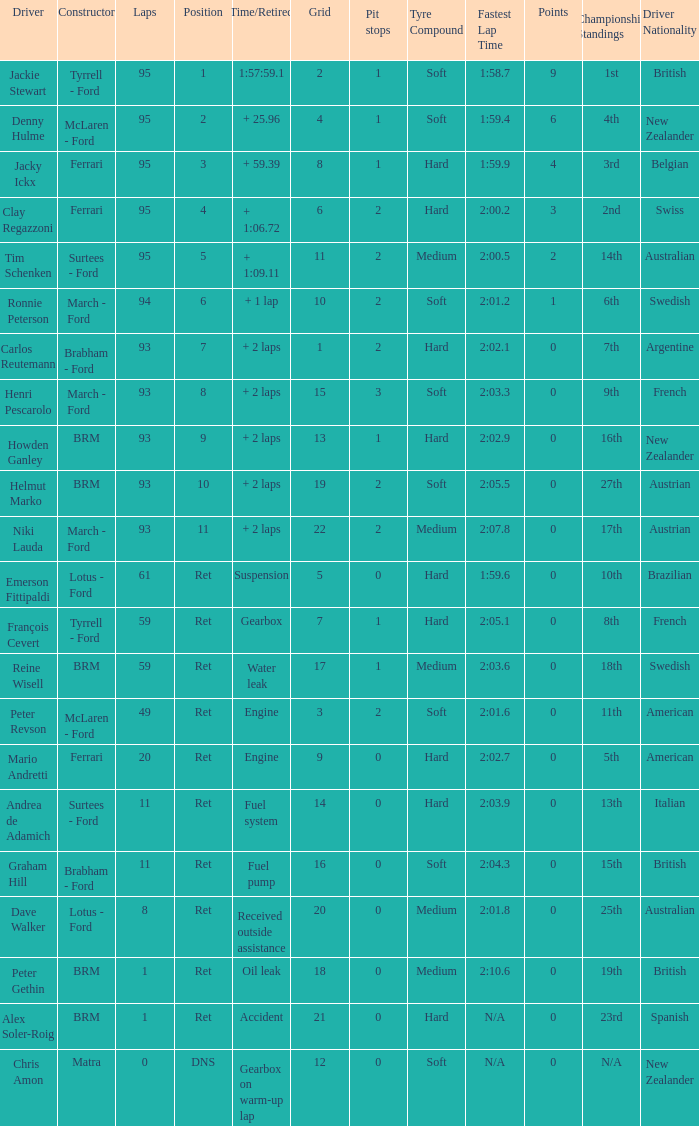What is the smallest grid that uses matra as its builder? 12.0. 